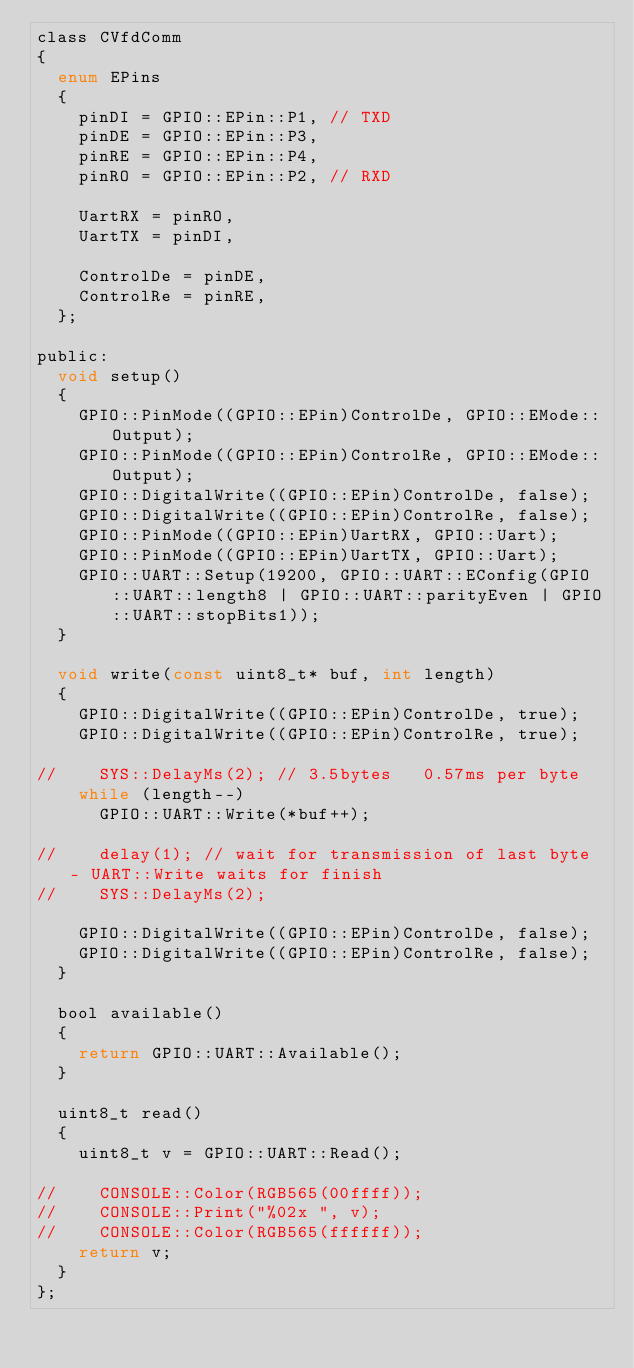<code> <loc_0><loc_0><loc_500><loc_500><_C_>class CVfdComm
{
  enum EPins
  {
    pinDI = GPIO::EPin::P1, // TXD
    pinDE = GPIO::EPin::P3,
    pinRE = GPIO::EPin::P4,
    pinRO = GPIO::EPin::P2, // RXD

    UartRX = pinRO,
    UartTX = pinDI,

    ControlDe = pinDE,
    ControlRe = pinRE,
  };
    
public:
  void setup()
  {    
    GPIO::PinMode((GPIO::EPin)ControlDe, GPIO::EMode::Output);
    GPIO::PinMode((GPIO::EPin)ControlRe, GPIO::EMode::Output);
    GPIO::DigitalWrite((GPIO::EPin)ControlDe, false);
    GPIO::DigitalWrite((GPIO::EPin)ControlRe, false);
    GPIO::PinMode((GPIO::EPin)UartRX, GPIO::Uart);
    GPIO::PinMode((GPIO::EPin)UartTX, GPIO::Uart);
    GPIO::UART::Setup(19200, GPIO::UART::EConfig(GPIO::UART::length8 | GPIO::UART::parityEven | GPIO::UART::stopBits1));
  }
  
  void write(const uint8_t* buf, int length)
  {
    GPIO::DigitalWrite((GPIO::EPin)ControlDe, true);
    GPIO::DigitalWrite((GPIO::EPin)ControlRe, true);
    
//    SYS::DelayMs(2); // 3.5bytes   0.57ms per byte    
    while (length--)
      GPIO::UART::Write(*buf++);
    
//    delay(1); // wait for transmission of last byte - UART::Write waits for finish
//    SYS::DelayMs(2); 
    
    GPIO::DigitalWrite((GPIO::EPin)ControlDe, false);
    GPIO::DigitalWrite((GPIO::EPin)ControlRe, false);        
  }

  bool available()
  {
    return GPIO::UART::Available();
  }

  uint8_t read()
  {
    uint8_t v = GPIO::UART::Read();

//    CONSOLE::Color(RGB565(00ffff));
//    CONSOLE::Print("%02x ", v);
//    CONSOLE::Color(RGB565(ffffff));
    return v;
  }
};
</code> 